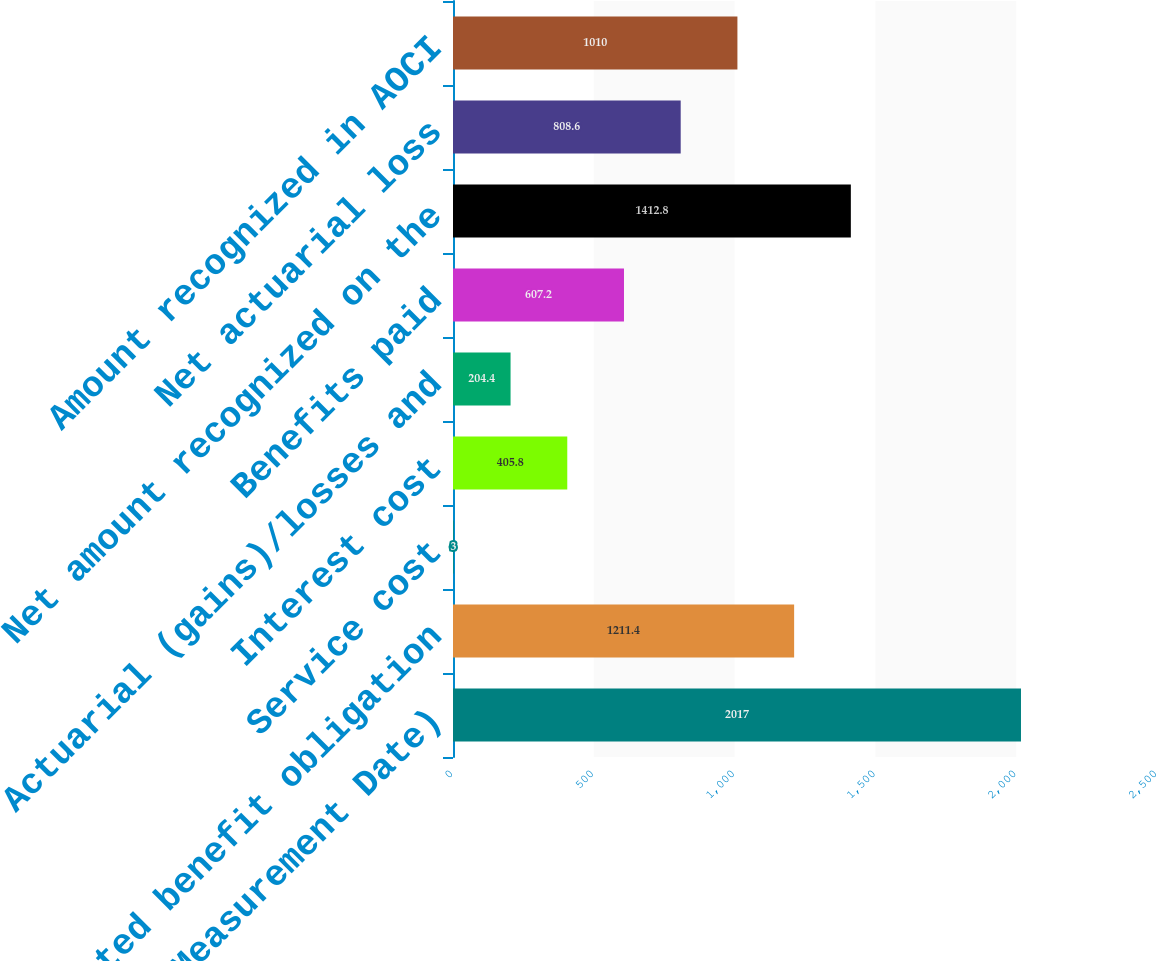Convert chart to OTSL. <chart><loc_0><loc_0><loc_500><loc_500><bar_chart><fcel>December 31 (Measurement Date)<fcel>Projected benefit obligation<fcel>Service cost<fcel>Interest cost<fcel>Actuarial (gains)/losses and<fcel>Benefits paid<fcel>Net amount recognized on the<fcel>Net actuarial loss<fcel>Amount recognized in AOCI<nl><fcel>2017<fcel>1211.4<fcel>3<fcel>405.8<fcel>204.4<fcel>607.2<fcel>1412.8<fcel>808.6<fcel>1010<nl></chart> 